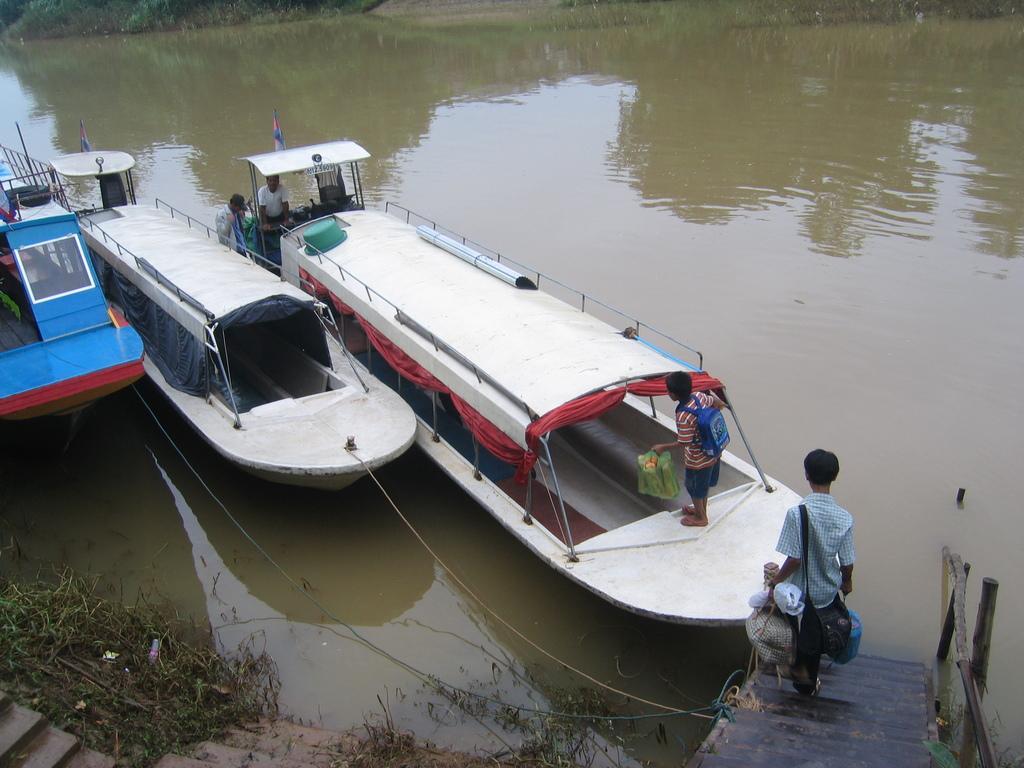In one or two sentences, can you explain what this image depicts? In this picture there are boats in the center and on the left side of the image, there is water around the area of the image and there is a dock at the bottom side of the image, there is a small boy on it. 